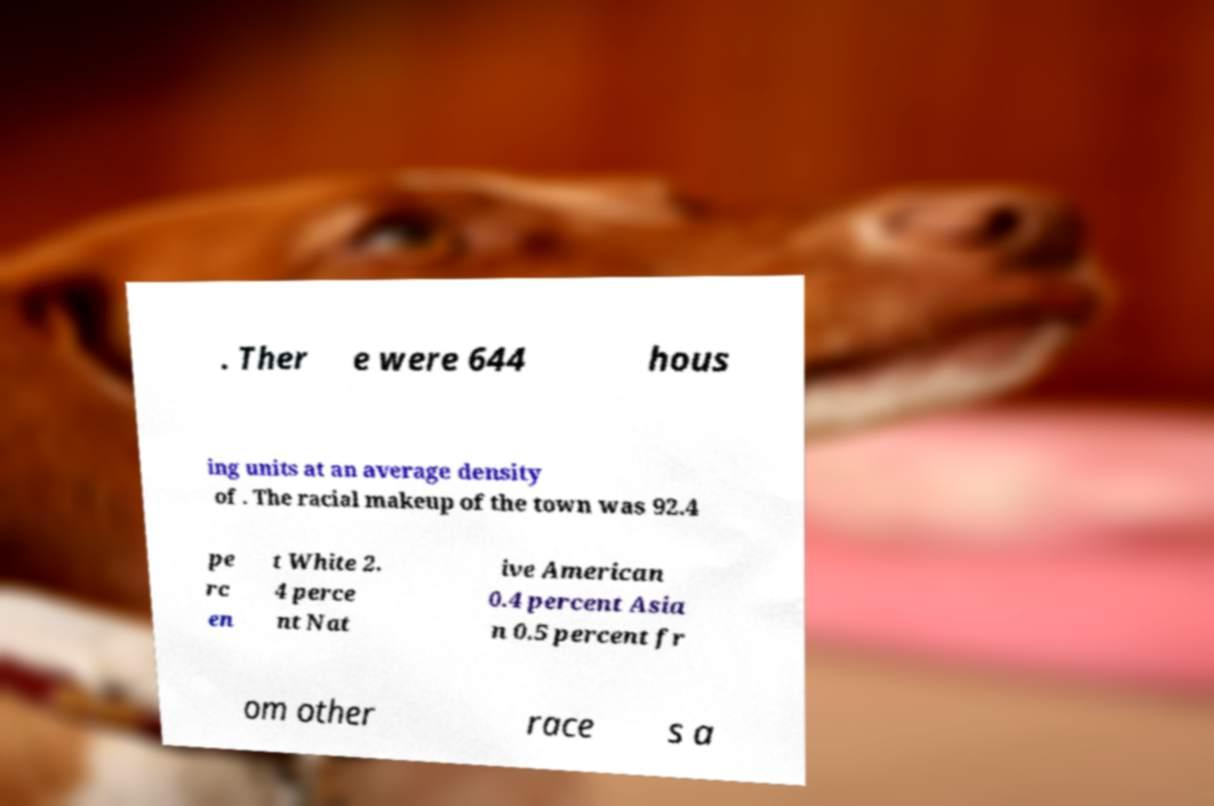There's text embedded in this image that I need extracted. Can you transcribe it verbatim? . Ther e were 644 hous ing units at an average density of . The racial makeup of the town was 92.4 pe rc en t White 2. 4 perce nt Nat ive American 0.4 percent Asia n 0.5 percent fr om other race s a 